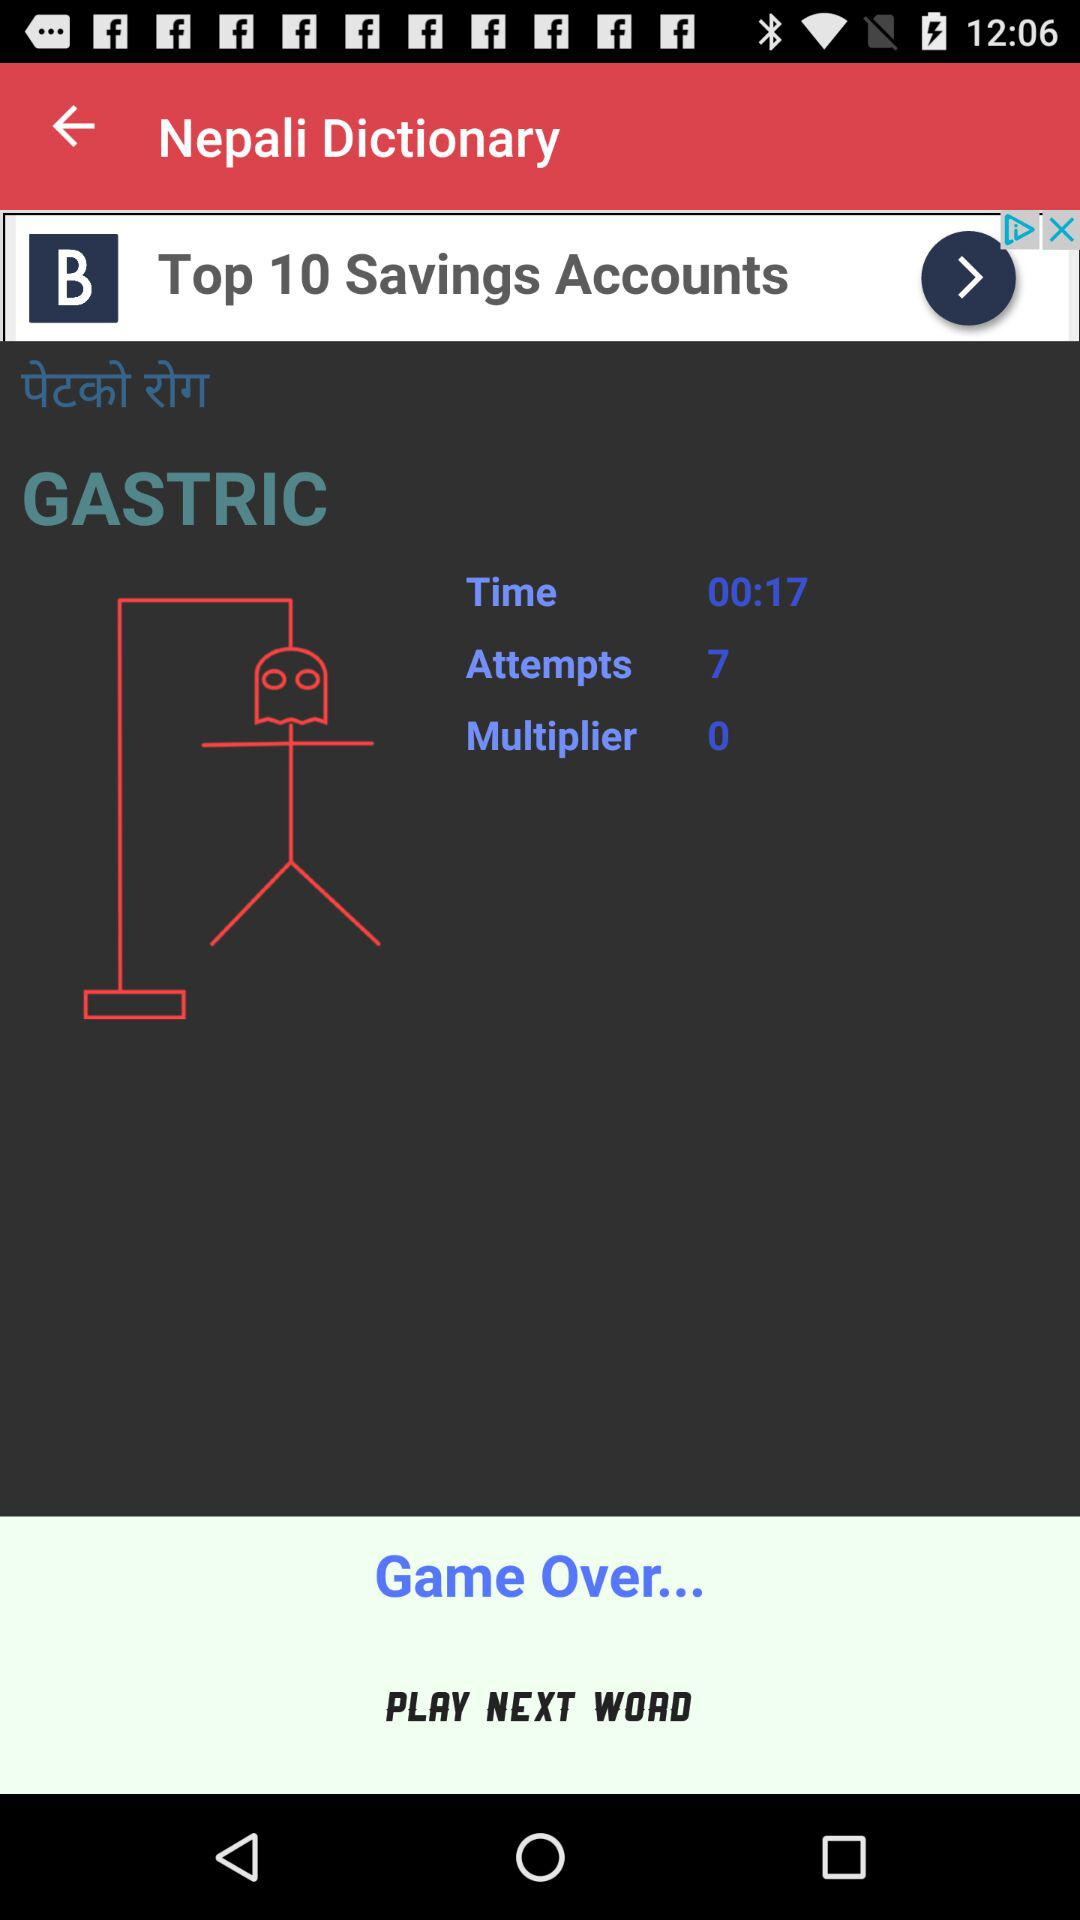What is the application name? The application name is "Nepali Dictionary". 